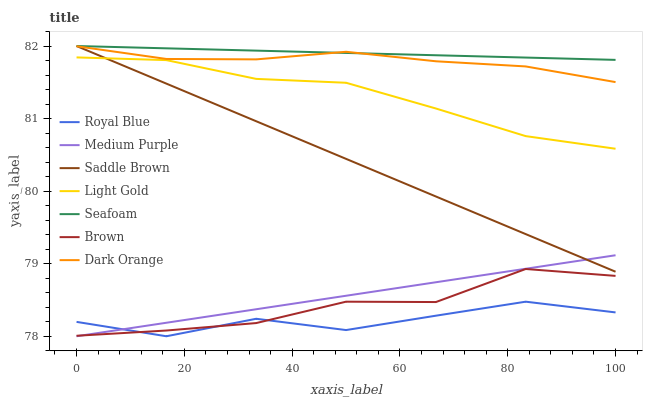Does Royal Blue have the minimum area under the curve?
Answer yes or no. Yes. Does Seafoam have the maximum area under the curve?
Answer yes or no. Yes. Does Dark Orange have the minimum area under the curve?
Answer yes or no. No. Does Dark Orange have the maximum area under the curve?
Answer yes or no. No. Is Seafoam the smoothest?
Answer yes or no. Yes. Is Royal Blue the roughest?
Answer yes or no. Yes. Is Dark Orange the smoothest?
Answer yes or no. No. Is Dark Orange the roughest?
Answer yes or no. No. Does Dark Orange have the lowest value?
Answer yes or no. No. Does Dark Orange have the highest value?
Answer yes or no. No. Is Brown less than Dark Orange?
Answer yes or no. Yes. Is Dark Orange greater than Light Gold?
Answer yes or no. Yes. Does Brown intersect Dark Orange?
Answer yes or no. No. 